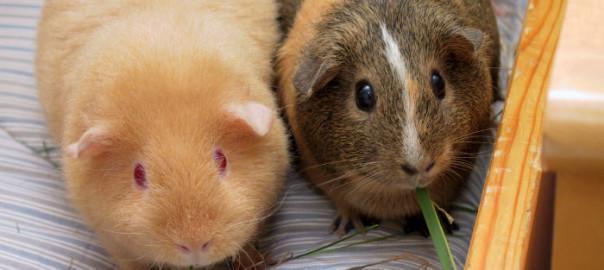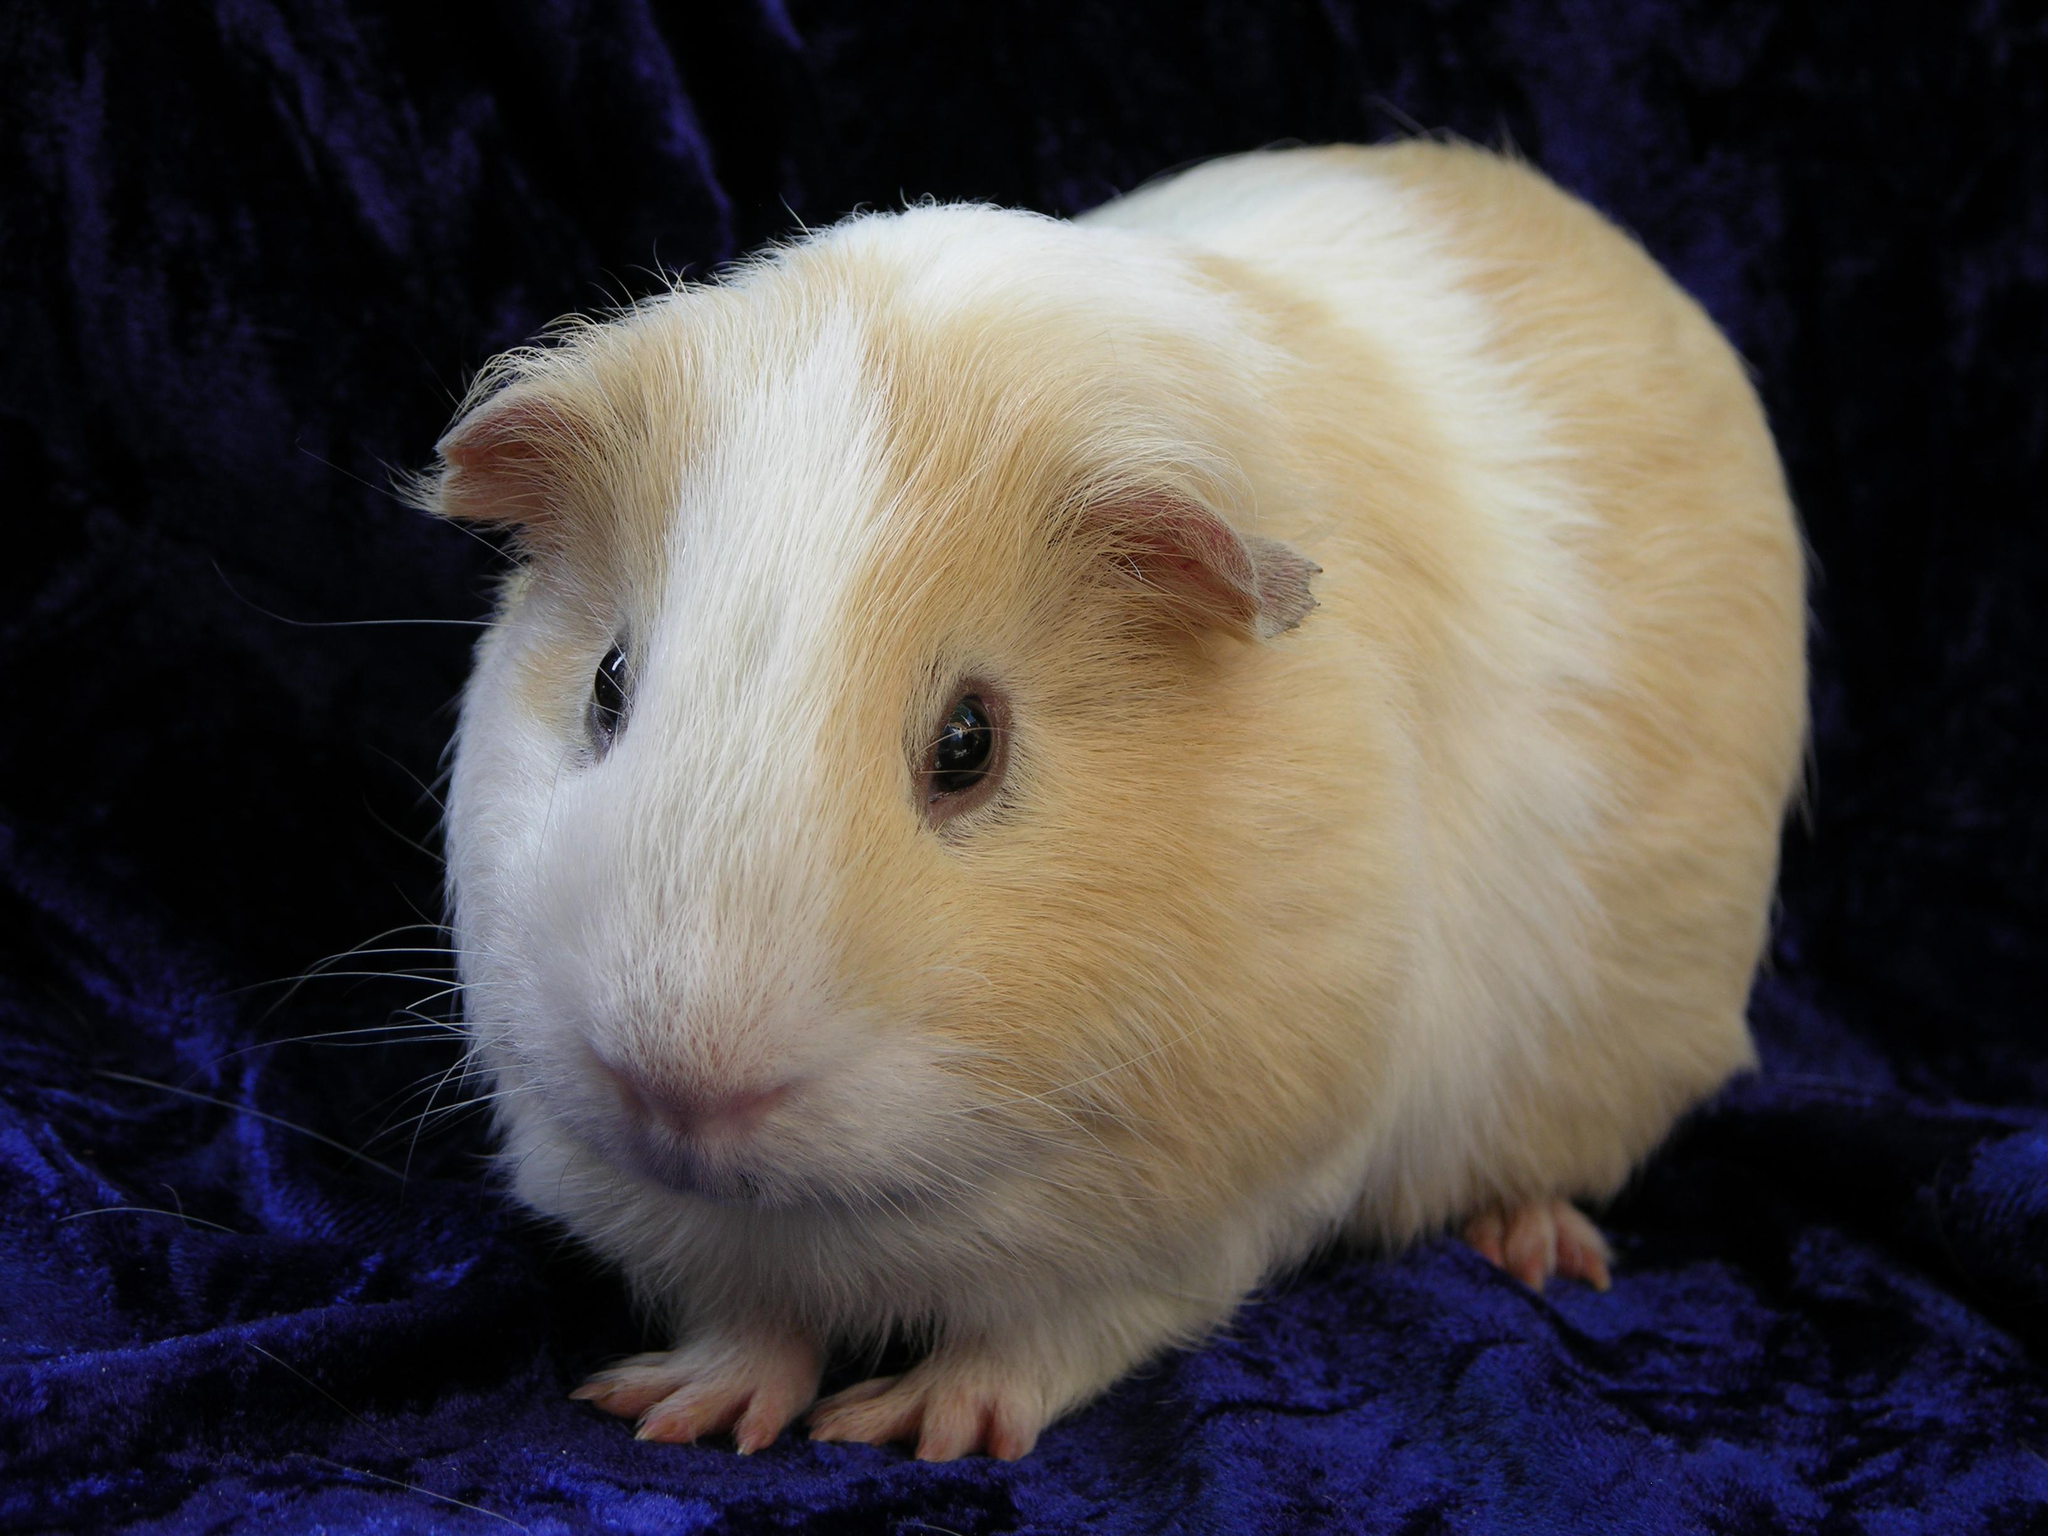The first image is the image on the left, the second image is the image on the right. For the images shown, is this caption "Each image contains a single guinea pig and only one guinea pig is standing on green grass." true? Answer yes or no. No. The first image is the image on the left, the second image is the image on the right. Evaluate the accuracy of this statement regarding the images: "At least one hamster is eating something in at least one of the images.". Is it true? Answer yes or no. Yes. 